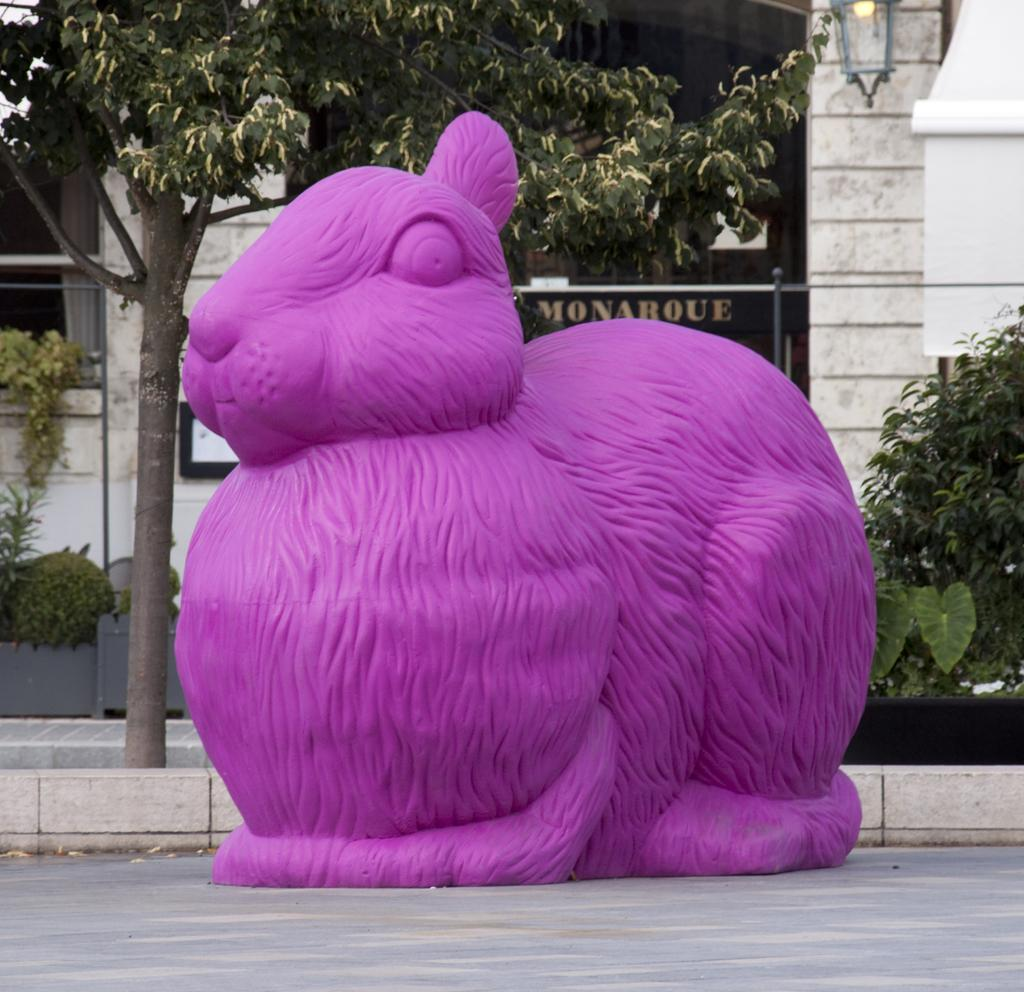What is the main subject in the middle of the image? There is a purple rabbit statue in the middle of the image. What type of vegetation can be seen in the image? There are plants and trees in the image. What is visible in the background of the image? There is a building in the background of the image. How many apples are hanging from the trees in the image? There are no apples visible in the image; only plants, trees, and a purple rabbit statue are present. 